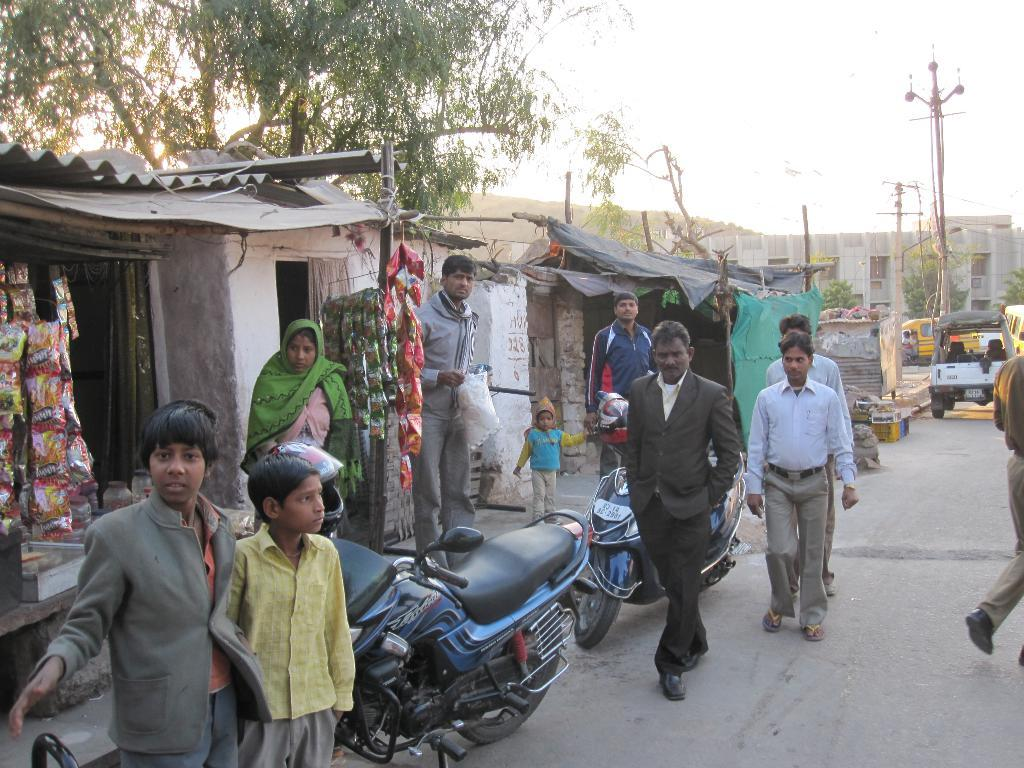How many people can be seen in the image? There are people in the image, but the exact number is not specified. What can be seen on the road in the image? There are vehicles on the road in the image. What type of structure is present in the image? There is a stall in the image. What other structures are visible in the image? There are sheds in the image. What else can be seen in the image? There are poles in the image. What is visible in the background of the image? There are trees, a building, and the sky visible in the background of the image. What type of furniture can be seen in the image? There is no furniture present in the image. What is the source of humor in the image? The image does not contain any humor or laughter. 